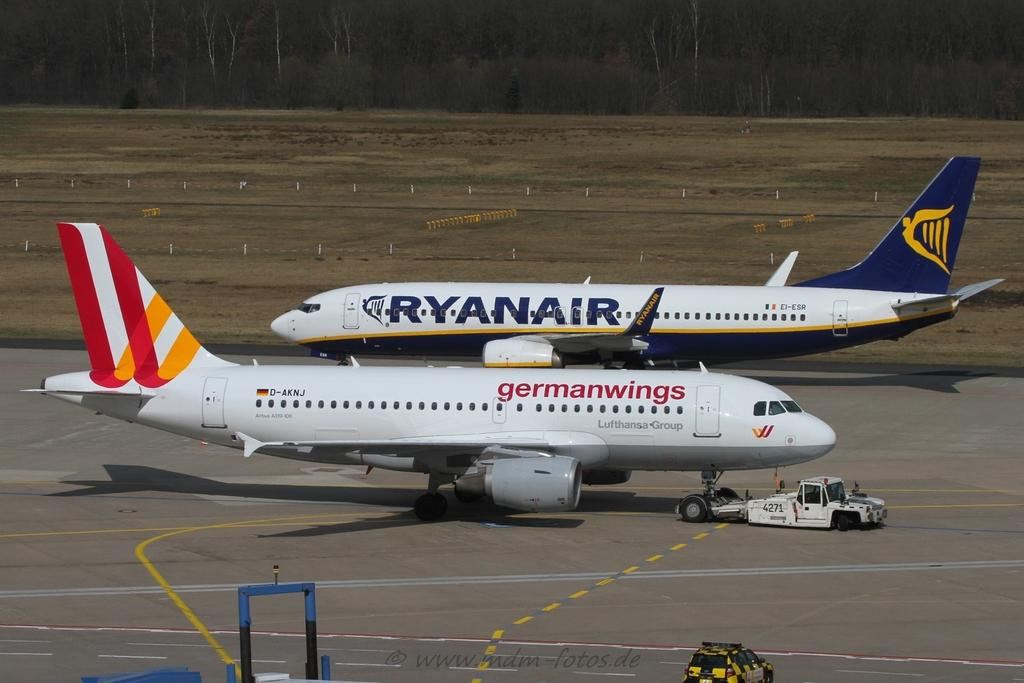<image>
Relay a brief, clear account of the picture shown. Two air planes sitting on a runway, one from ryanair and one from germanwings. 